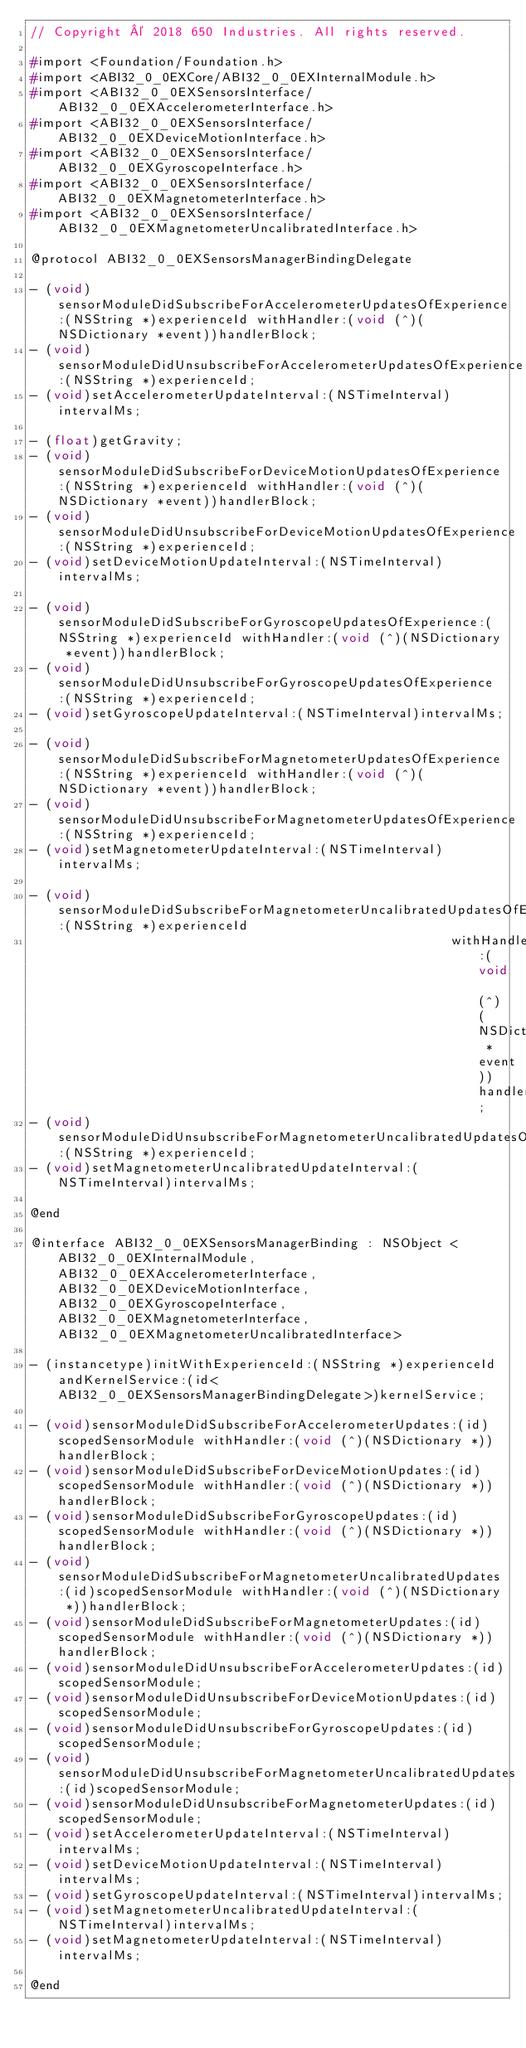<code> <loc_0><loc_0><loc_500><loc_500><_C_>// Copyright © 2018 650 Industries. All rights reserved.

#import <Foundation/Foundation.h>
#import <ABI32_0_0EXCore/ABI32_0_0EXInternalModule.h>
#import <ABI32_0_0EXSensorsInterface/ABI32_0_0EXAccelerometerInterface.h>
#import <ABI32_0_0EXSensorsInterface/ABI32_0_0EXDeviceMotionInterface.h>
#import <ABI32_0_0EXSensorsInterface/ABI32_0_0EXGyroscopeInterface.h>
#import <ABI32_0_0EXSensorsInterface/ABI32_0_0EXMagnetometerInterface.h>
#import <ABI32_0_0EXSensorsInterface/ABI32_0_0EXMagnetometerUncalibratedInterface.h>

@protocol ABI32_0_0EXSensorsManagerBindingDelegate

- (void)sensorModuleDidSubscribeForAccelerometerUpdatesOfExperience:(NSString *)experienceId withHandler:(void (^)(NSDictionary *event))handlerBlock;
- (void)sensorModuleDidUnsubscribeForAccelerometerUpdatesOfExperience:(NSString *)experienceId;
- (void)setAccelerometerUpdateInterval:(NSTimeInterval)intervalMs;

- (float)getGravity;
- (void)sensorModuleDidSubscribeForDeviceMotionUpdatesOfExperience:(NSString *)experienceId withHandler:(void (^)(NSDictionary *event))handlerBlock;
- (void)sensorModuleDidUnsubscribeForDeviceMotionUpdatesOfExperience:(NSString *)experienceId;
- (void)setDeviceMotionUpdateInterval:(NSTimeInterval)intervalMs;

- (void)sensorModuleDidSubscribeForGyroscopeUpdatesOfExperience:(NSString *)experienceId withHandler:(void (^)(NSDictionary *event))handlerBlock;
- (void)sensorModuleDidUnsubscribeForGyroscopeUpdatesOfExperience:(NSString *)experienceId;
- (void)setGyroscopeUpdateInterval:(NSTimeInterval)intervalMs;

- (void)sensorModuleDidSubscribeForMagnetometerUpdatesOfExperience:(NSString *)experienceId withHandler:(void (^)(NSDictionary *event))handlerBlock;
- (void)sensorModuleDidUnsubscribeForMagnetometerUpdatesOfExperience:(NSString *)experienceId;
- (void)setMagnetometerUpdateInterval:(NSTimeInterval)intervalMs;

- (void)sensorModuleDidSubscribeForMagnetometerUncalibratedUpdatesOfExperience:(NSString *)experienceId
                                                       withHandler:(void (^)(NSDictionary *event))handlerBlock;
- (void)sensorModuleDidUnsubscribeForMagnetometerUncalibratedUpdatesOfExperience:(NSString *)experienceId;
- (void)setMagnetometerUncalibratedUpdateInterval:(NSTimeInterval)intervalMs;

@end

@interface ABI32_0_0EXSensorsManagerBinding : NSObject <ABI32_0_0EXInternalModule, ABI32_0_0EXAccelerometerInterface, ABI32_0_0EXDeviceMotionInterface, ABI32_0_0EXGyroscopeInterface, ABI32_0_0EXMagnetometerInterface, ABI32_0_0EXMagnetometerUncalibratedInterface>

- (instancetype)initWithExperienceId:(NSString *)experienceId andKernelService:(id<ABI32_0_0EXSensorsManagerBindingDelegate>)kernelService;

- (void)sensorModuleDidSubscribeForAccelerometerUpdates:(id)scopedSensorModule withHandler:(void (^)(NSDictionary *))handlerBlock;
- (void)sensorModuleDidSubscribeForDeviceMotionUpdates:(id)scopedSensorModule withHandler:(void (^)(NSDictionary *))handlerBlock;
- (void)sensorModuleDidSubscribeForGyroscopeUpdates:(id)scopedSensorModule withHandler:(void (^)(NSDictionary *))handlerBlock;
- (void)sensorModuleDidSubscribeForMagnetometerUncalibratedUpdates:(id)scopedSensorModule withHandler:(void (^)(NSDictionary *))handlerBlock;
- (void)sensorModuleDidSubscribeForMagnetometerUpdates:(id)scopedSensorModule withHandler:(void (^)(NSDictionary *))handlerBlock;
- (void)sensorModuleDidUnsubscribeForAccelerometerUpdates:(id)scopedSensorModule;
- (void)sensorModuleDidUnsubscribeForDeviceMotionUpdates:(id)scopedSensorModule;
- (void)sensorModuleDidUnsubscribeForGyroscopeUpdates:(id)scopedSensorModule;
- (void)sensorModuleDidUnsubscribeForMagnetometerUncalibratedUpdates:(id)scopedSensorModule;
- (void)sensorModuleDidUnsubscribeForMagnetometerUpdates:(id)scopedSensorModule;
- (void)setAccelerometerUpdateInterval:(NSTimeInterval)intervalMs;
- (void)setDeviceMotionUpdateInterval:(NSTimeInterval)intervalMs;
- (void)setGyroscopeUpdateInterval:(NSTimeInterval)intervalMs;
- (void)setMagnetometerUncalibratedUpdateInterval:(NSTimeInterval)intervalMs;
- (void)setMagnetometerUpdateInterval:(NSTimeInterval)intervalMs;

@end
</code> 